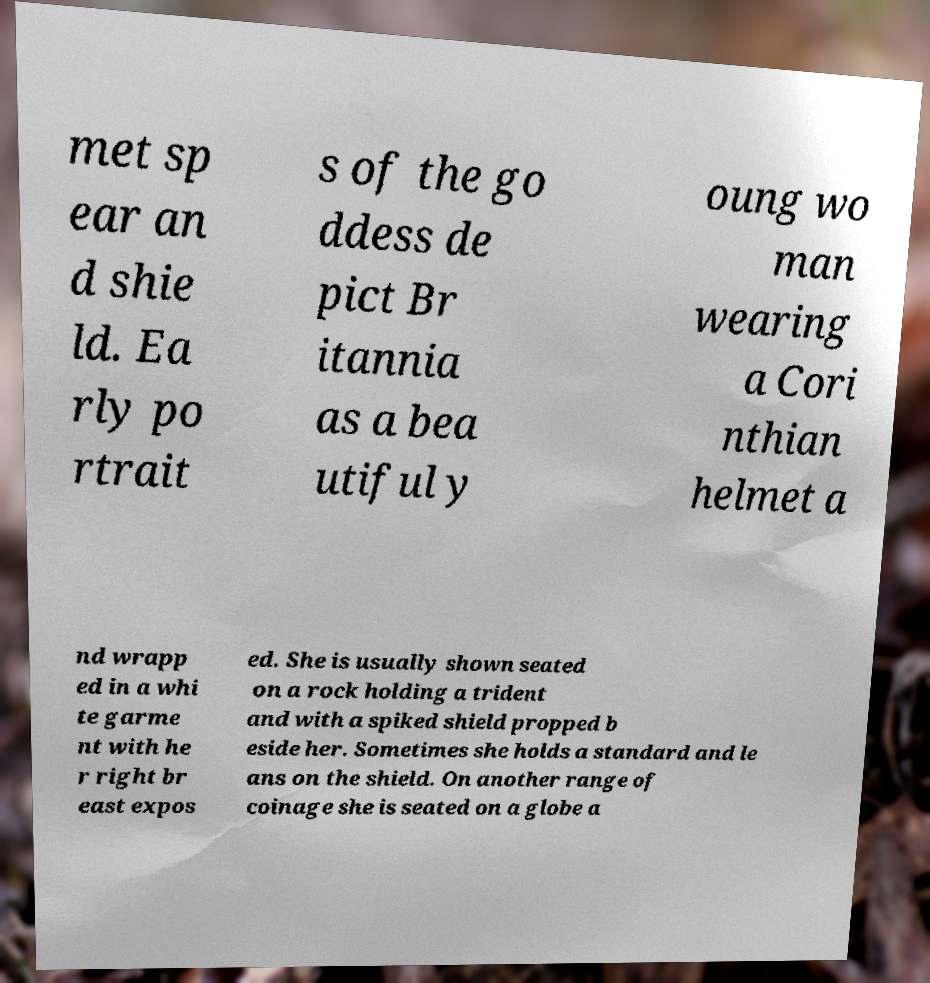Please identify and transcribe the text found in this image. met sp ear an d shie ld. Ea rly po rtrait s of the go ddess de pict Br itannia as a bea utiful y oung wo man wearing a Cori nthian helmet a nd wrapp ed in a whi te garme nt with he r right br east expos ed. She is usually shown seated on a rock holding a trident and with a spiked shield propped b eside her. Sometimes she holds a standard and le ans on the shield. On another range of coinage she is seated on a globe a 